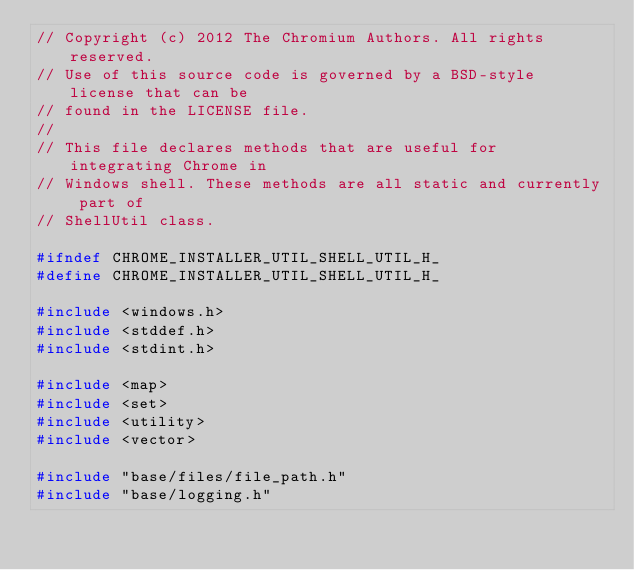Convert code to text. <code><loc_0><loc_0><loc_500><loc_500><_C_>// Copyright (c) 2012 The Chromium Authors. All rights reserved.
// Use of this source code is governed by a BSD-style license that can be
// found in the LICENSE file.
//
// This file declares methods that are useful for integrating Chrome in
// Windows shell. These methods are all static and currently part of
// ShellUtil class.

#ifndef CHROME_INSTALLER_UTIL_SHELL_UTIL_H_
#define CHROME_INSTALLER_UTIL_SHELL_UTIL_H_

#include <windows.h>
#include <stddef.h>
#include <stdint.h>

#include <map>
#include <set>
#include <utility>
#include <vector>

#include "base/files/file_path.h"
#include "base/logging.h"</code> 